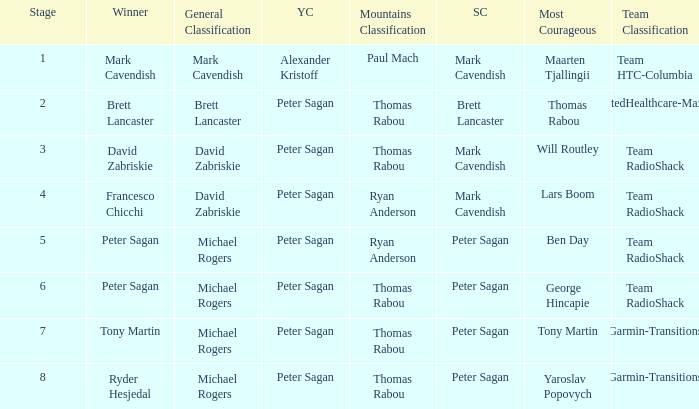Can you parse all the data within this table? {'header': ['Stage', 'Winner', 'General Classification', 'YC', 'Mountains Classification', 'SC', 'Most Courageous', 'Team Classification'], 'rows': [['1', 'Mark Cavendish', 'Mark Cavendish', 'Alexander Kristoff', 'Paul Mach', 'Mark Cavendish', 'Maarten Tjallingii', 'Team HTC-Columbia'], ['2', 'Brett Lancaster', 'Brett Lancaster', 'Peter Sagan', 'Thomas Rabou', 'Brett Lancaster', 'Thomas Rabou', 'UnitedHealthcare-Maxxis'], ['3', 'David Zabriskie', 'David Zabriskie', 'Peter Sagan', 'Thomas Rabou', 'Mark Cavendish', 'Will Routley', 'Team RadioShack'], ['4', 'Francesco Chicchi', 'David Zabriskie', 'Peter Sagan', 'Ryan Anderson', 'Mark Cavendish', 'Lars Boom', 'Team RadioShack'], ['5', 'Peter Sagan', 'Michael Rogers', 'Peter Sagan', 'Ryan Anderson', 'Peter Sagan', 'Ben Day', 'Team RadioShack'], ['6', 'Peter Sagan', 'Michael Rogers', 'Peter Sagan', 'Thomas Rabou', 'Peter Sagan', 'George Hincapie', 'Team RadioShack'], ['7', 'Tony Martin', 'Michael Rogers', 'Peter Sagan', 'Thomas Rabou', 'Peter Sagan', 'Tony Martin', 'Garmin-Transitions'], ['8', 'Ryder Hesjedal', 'Michael Rogers', 'Peter Sagan', 'Thomas Rabou', 'Peter Sagan', 'Yaroslav Popovych', 'Garmin-Transitions']]} Who won the mountains classification when Maarten Tjallingii won most corageous? Paul Mach. 